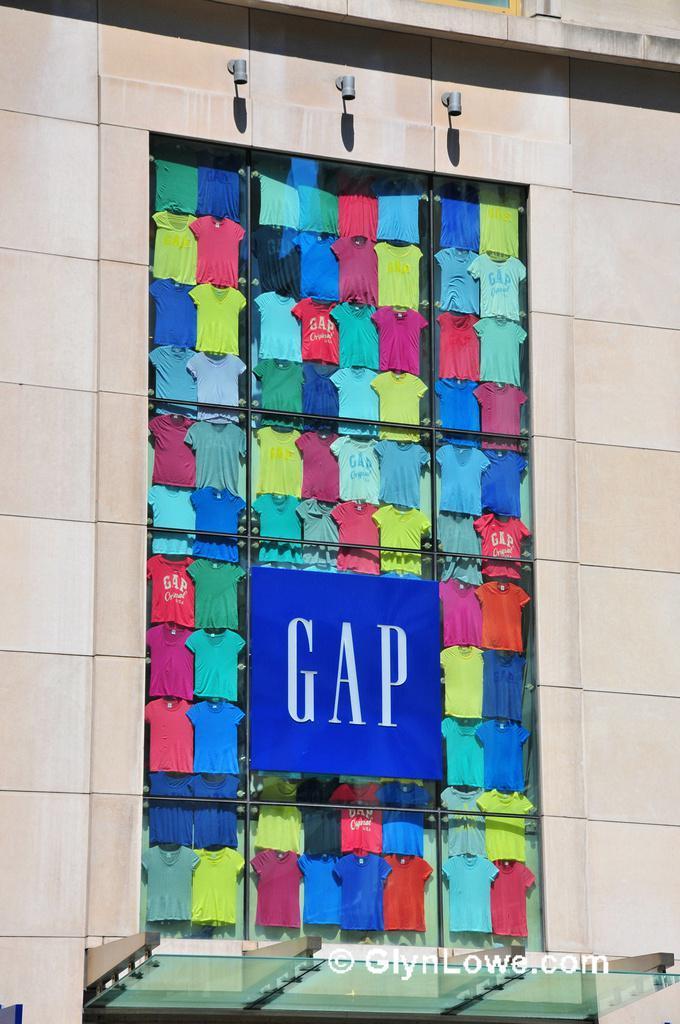Describe this image in one or two sentences. In this image we can see a building with window. We can also see a group of t-shirts from a window, a name board and some lights. On the bottom of the image we can see some text. 